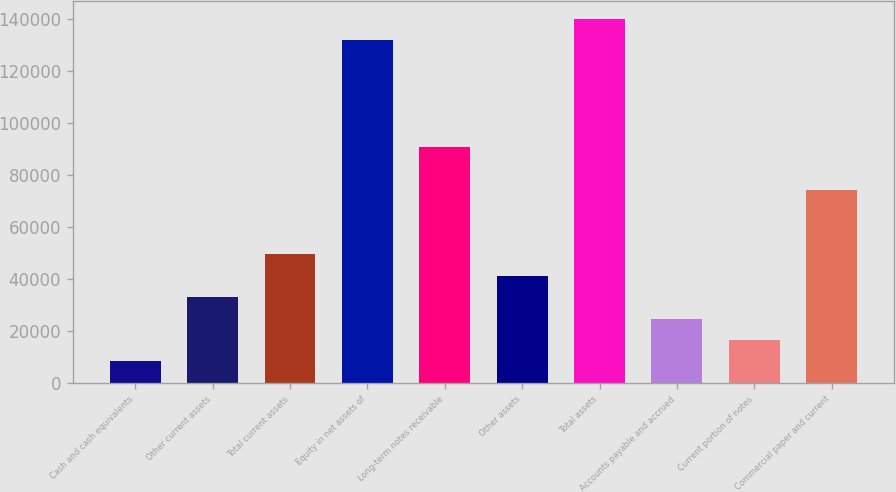Convert chart. <chart><loc_0><loc_0><loc_500><loc_500><bar_chart><fcel>Cash and cash equivalents<fcel>Other current assets<fcel>Total current assets<fcel>Equity in net assets of<fcel>Long-term notes receivable<fcel>Other assets<fcel>Total assets<fcel>Accounts payable and accrued<fcel>Current portion of notes<fcel>Commercial paper and current<nl><fcel>8237.2<fcel>32918.8<fcel>49373.2<fcel>131645<fcel>90509.2<fcel>41146<fcel>139872<fcel>24691.6<fcel>16464.4<fcel>74054.8<nl></chart> 